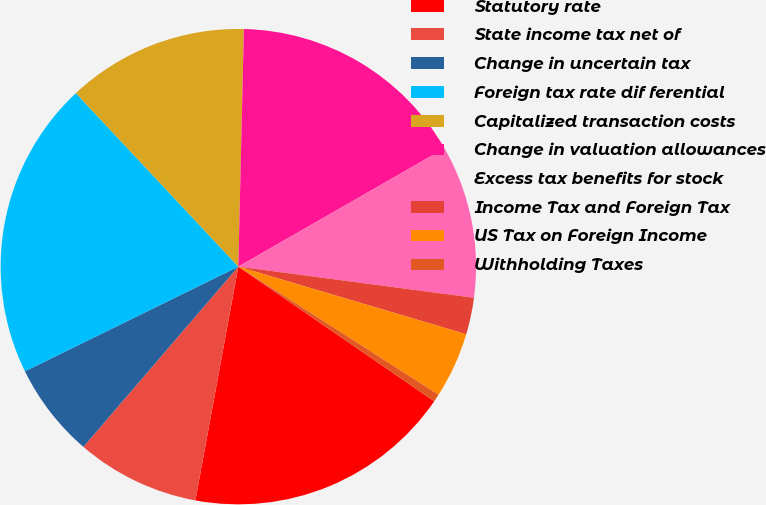<chart> <loc_0><loc_0><loc_500><loc_500><pie_chart><fcel>Statutory rate<fcel>State income tax net of<fcel>Change in uncertain tax<fcel>Foreign tax rate dif ferential<fcel>Capitalized transaction costs<fcel>Change in valuation allowances<fcel>Excess tax benefits for stock<fcel>Income Tax and Foreign Tax<fcel>US Tax on Foreign Income<fcel>Withholding Taxes<nl><fcel>18.31%<fcel>8.41%<fcel>6.44%<fcel>20.28%<fcel>12.35%<fcel>16.34%<fcel>10.38%<fcel>2.5%<fcel>4.47%<fcel>0.52%<nl></chart> 